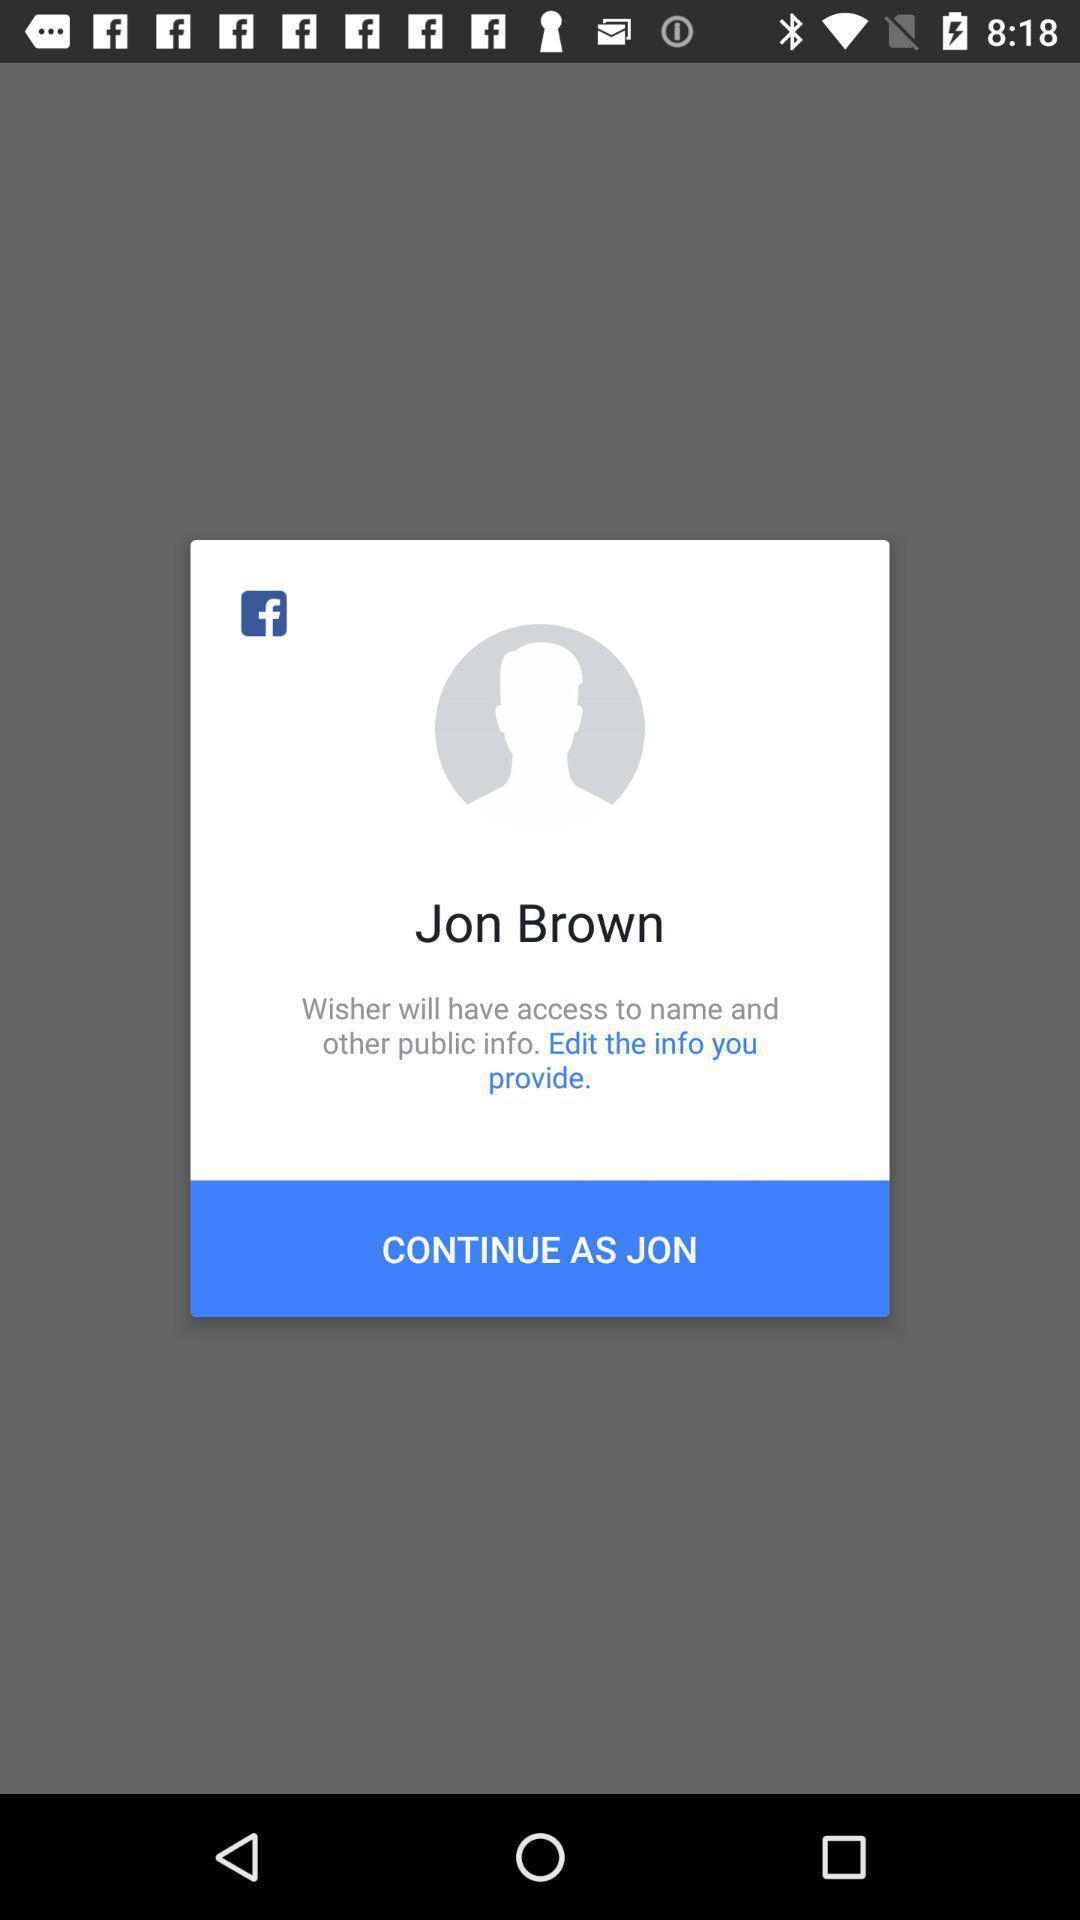Describe the key features of this screenshot. Pop up suggesting to continue with existing account. 